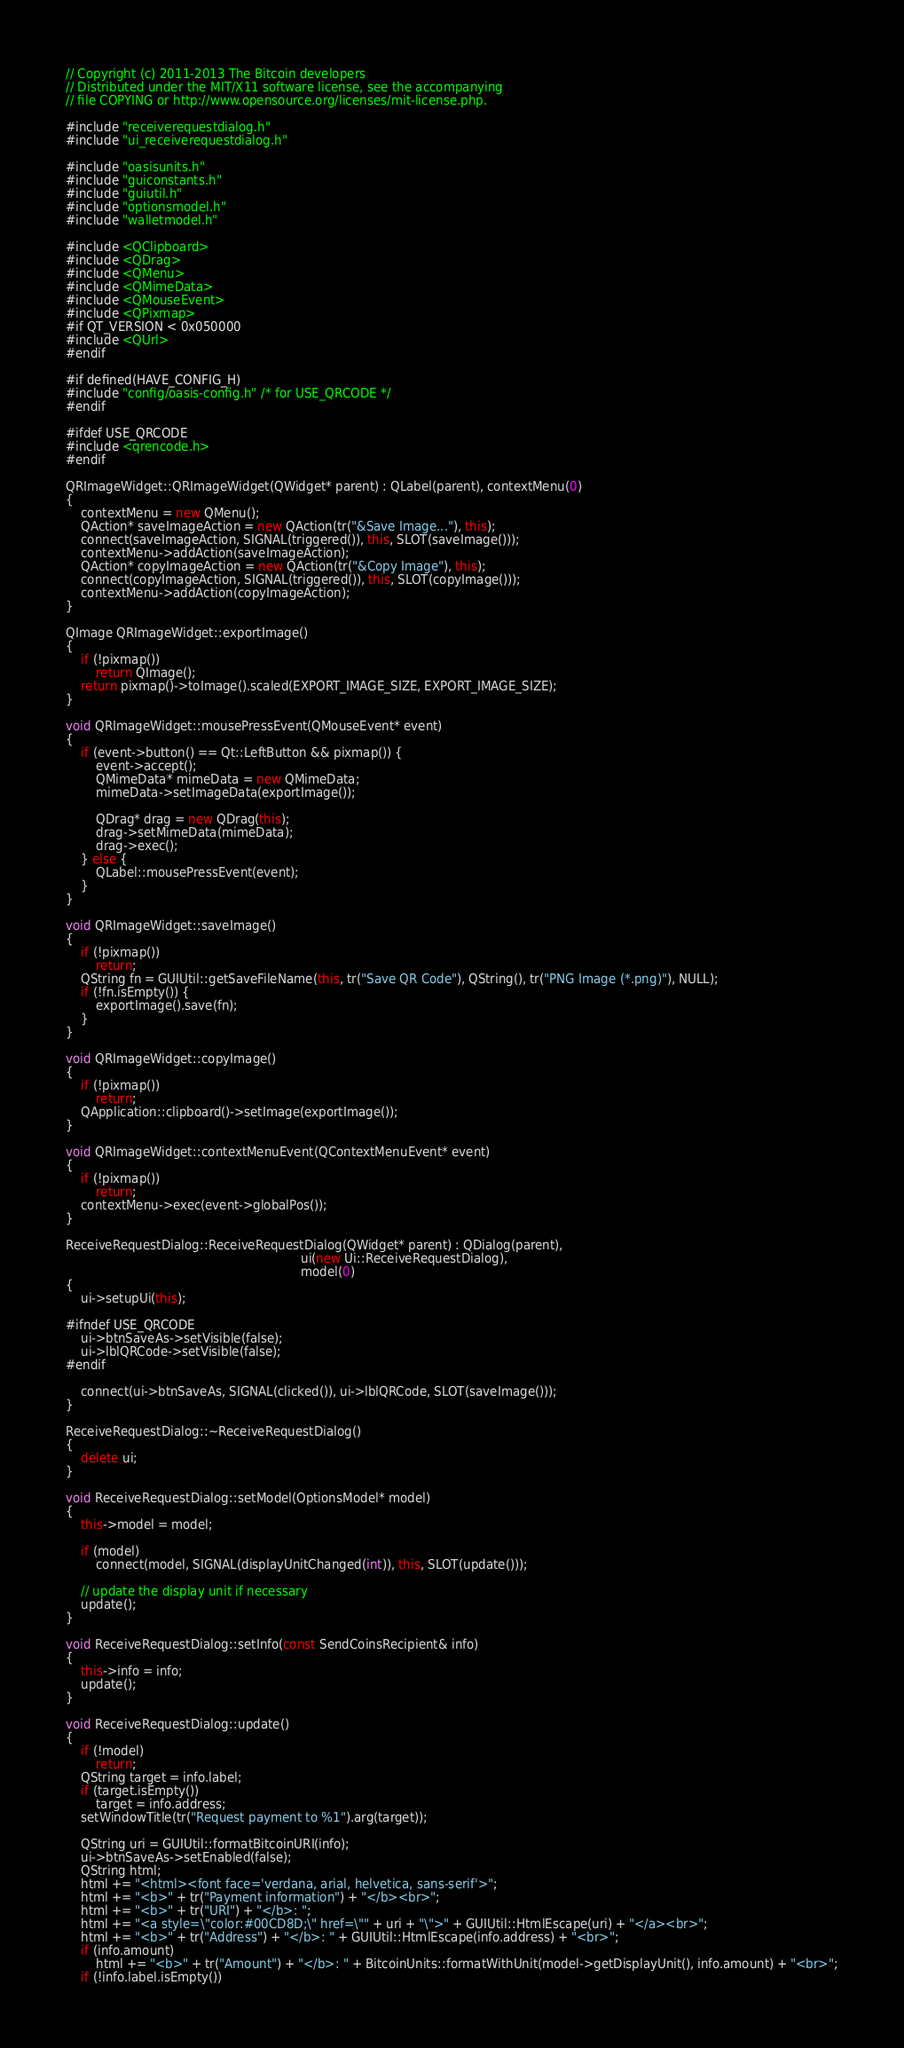Convert code to text. <code><loc_0><loc_0><loc_500><loc_500><_C++_>// Copyright (c) 2011-2013 The Bitcoin developers
// Distributed under the MIT/X11 software license, see the accompanying
// file COPYING or http://www.opensource.org/licenses/mit-license.php.

#include "receiverequestdialog.h"
#include "ui_receiverequestdialog.h"

#include "oasisunits.h"
#include "guiconstants.h"
#include "guiutil.h"
#include "optionsmodel.h"
#include "walletmodel.h"

#include <QClipboard>
#include <QDrag>
#include <QMenu>
#include <QMimeData>
#include <QMouseEvent>
#include <QPixmap>
#if QT_VERSION < 0x050000
#include <QUrl>
#endif

#if defined(HAVE_CONFIG_H)
#include "config/oasis-config.h" /* for USE_QRCODE */
#endif

#ifdef USE_QRCODE
#include <qrencode.h>
#endif

QRImageWidget::QRImageWidget(QWidget* parent) : QLabel(parent), contextMenu(0)
{
    contextMenu = new QMenu();
    QAction* saveImageAction = new QAction(tr("&Save Image..."), this);
    connect(saveImageAction, SIGNAL(triggered()), this, SLOT(saveImage()));
    contextMenu->addAction(saveImageAction);
    QAction* copyImageAction = new QAction(tr("&Copy Image"), this);
    connect(copyImageAction, SIGNAL(triggered()), this, SLOT(copyImage()));
    contextMenu->addAction(copyImageAction);
}

QImage QRImageWidget::exportImage()
{
    if (!pixmap())
        return QImage();
    return pixmap()->toImage().scaled(EXPORT_IMAGE_SIZE, EXPORT_IMAGE_SIZE);
}

void QRImageWidget::mousePressEvent(QMouseEvent* event)
{
    if (event->button() == Qt::LeftButton && pixmap()) {
        event->accept();
        QMimeData* mimeData = new QMimeData;
        mimeData->setImageData(exportImage());

        QDrag* drag = new QDrag(this);
        drag->setMimeData(mimeData);
        drag->exec();
    } else {
        QLabel::mousePressEvent(event);
    }
}

void QRImageWidget::saveImage()
{
    if (!pixmap())
        return;
    QString fn = GUIUtil::getSaveFileName(this, tr("Save QR Code"), QString(), tr("PNG Image (*.png)"), NULL);
    if (!fn.isEmpty()) {
        exportImage().save(fn);
    }
}

void QRImageWidget::copyImage()
{
    if (!pixmap())
        return;
    QApplication::clipboard()->setImage(exportImage());
}

void QRImageWidget::contextMenuEvent(QContextMenuEvent* event)
{
    if (!pixmap())
        return;
    contextMenu->exec(event->globalPos());
}

ReceiveRequestDialog::ReceiveRequestDialog(QWidget* parent) : QDialog(parent),
                                                              ui(new Ui::ReceiveRequestDialog),
                                                              model(0)
{
    ui->setupUi(this);

#ifndef USE_QRCODE
    ui->btnSaveAs->setVisible(false);
    ui->lblQRCode->setVisible(false);
#endif

    connect(ui->btnSaveAs, SIGNAL(clicked()), ui->lblQRCode, SLOT(saveImage()));
}

ReceiveRequestDialog::~ReceiveRequestDialog()
{
    delete ui;
}

void ReceiveRequestDialog::setModel(OptionsModel* model)
{
    this->model = model;

    if (model)
        connect(model, SIGNAL(displayUnitChanged(int)), this, SLOT(update()));

    // update the display unit if necessary
    update();
}

void ReceiveRequestDialog::setInfo(const SendCoinsRecipient& info)
{
    this->info = info;
    update();
}

void ReceiveRequestDialog::update()
{
    if (!model)
        return;
    QString target = info.label;
    if (target.isEmpty())
        target = info.address;
    setWindowTitle(tr("Request payment to %1").arg(target));

    QString uri = GUIUtil::formatBitcoinURI(info);
    ui->btnSaveAs->setEnabled(false);
    QString html;
    html += "<html><font face='verdana, arial, helvetica, sans-serif'>";
    html += "<b>" + tr("Payment information") + "</b><br>";
    html += "<b>" + tr("URI") + "</b>: ";
    html += "<a style=\"color:#00CD8D;\" href=\"" + uri + "\">" + GUIUtil::HtmlEscape(uri) + "</a><br>";
    html += "<b>" + tr("Address") + "</b>: " + GUIUtil::HtmlEscape(info.address) + "<br>";
    if (info.amount)
        html += "<b>" + tr("Amount") + "</b>: " + BitcoinUnits::formatWithUnit(model->getDisplayUnit(), info.amount) + "<br>";
    if (!info.label.isEmpty())</code> 